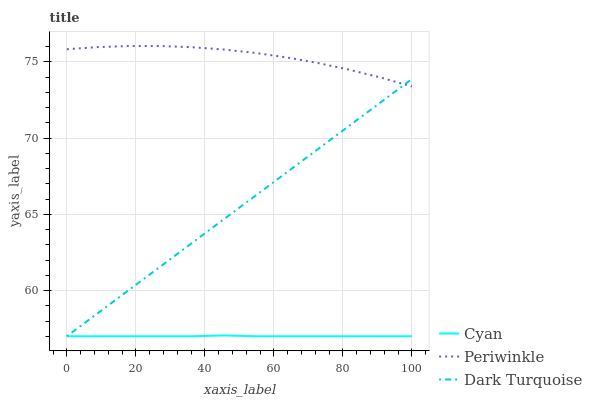Does Cyan have the minimum area under the curve?
Answer yes or no. Yes. Does Periwinkle have the maximum area under the curve?
Answer yes or no. Yes. Does Dark Turquoise have the minimum area under the curve?
Answer yes or no. No. Does Dark Turquoise have the maximum area under the curve?
Answer yes or no. No. Is Dark Turquoise the smoothest?
Answer yes or no. Yes. Is Periwinkle the roughest?
Answer yes or no. Yes. Is Periwinkle the smoothest?
Answer yes or no. No. Is Dark Turquoise the roughest?
Answer yes or no. No. Does Periwinkle have the lowest value?
Answer yes or no. No. Does Periwinkle have the highest value?
Answer yes or no. Yes. Does Dark Turquoise have the highest value?
Answer yes or no. No. Is Cyan less than Periwinkle?
Answer yes or no. Yes. Is Periwinkle greater than Cyan?
Answer yes or no. Yes. Does Periwinkle intersect Dark Turquoise?
Answer yes or no. Yes. Is Periwinkle less than Dark Turquoise?
Answer yes or no. No. Is Periwinkle greater than Dark Turquoise?
Answer yes or no. No. Does Cyan intersect Periwinkle?
Answer yes or no. No. 